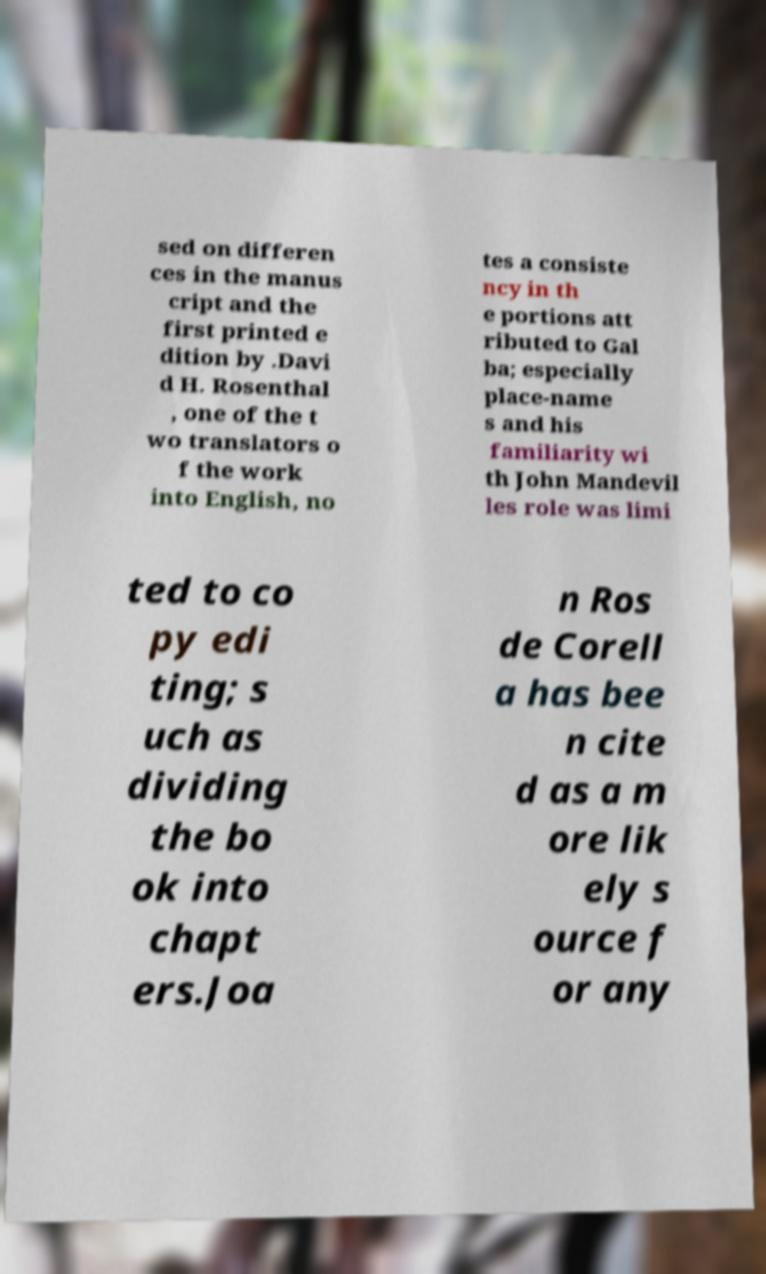I need the written content from this picture converted into text. Can you do that? sed on differen ces in the manus cript and the first printed e dition by .Davi d H. Rosenthal , one of the t wo translators o f the work into English, no tes a consiste ncy in th e portions att ributed to Gal ba; especially place-name s and his familiarity wi th John Mandevil les role was limi ted to co py edi ting; s uch as dividing the bo ok into chapt ers.Joa n Ros de Corell a has bee n cite d as a m ore lik ely s ource f or any 